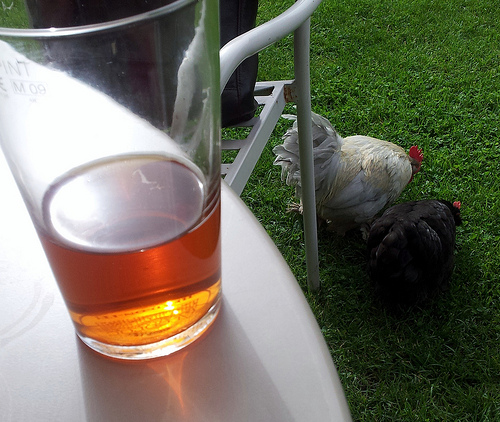<image>
Is there a glass above the table? No. The glass is not positioned above the table. The vertical arrangement shows a different relationship. 